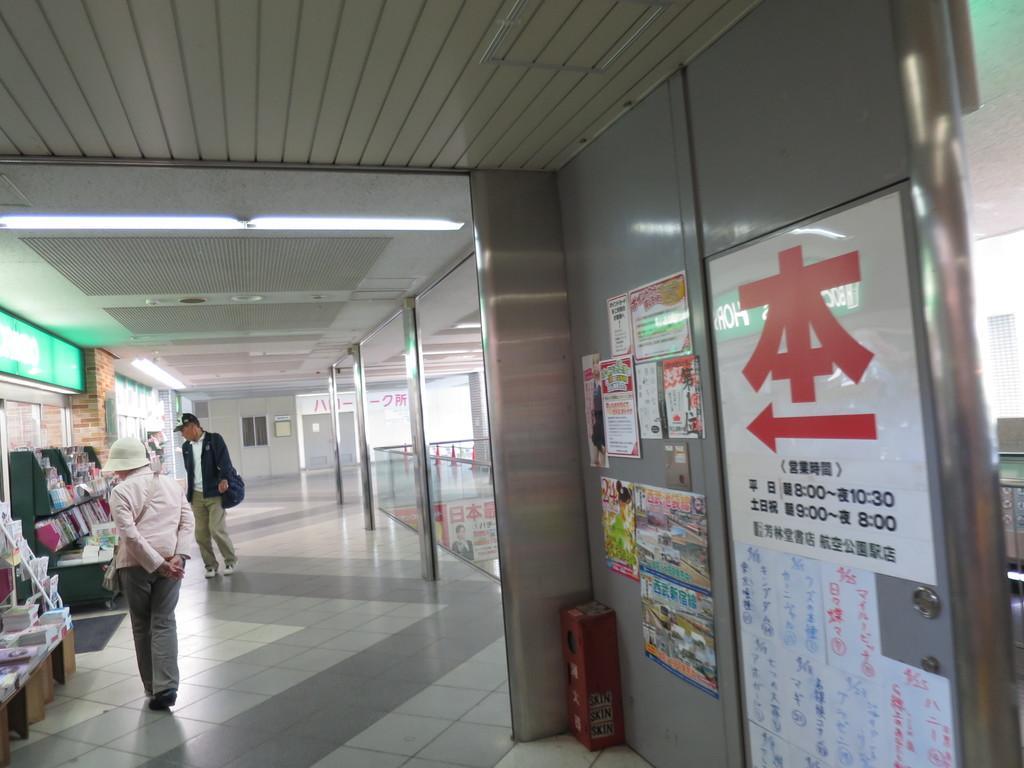Please provide a concise description of this image. On the left side of the image we can see persons on the floor and some books placed on the rack. On the right side of the image we can see posts on the wall. In the background there is a door, pillars and wall. 